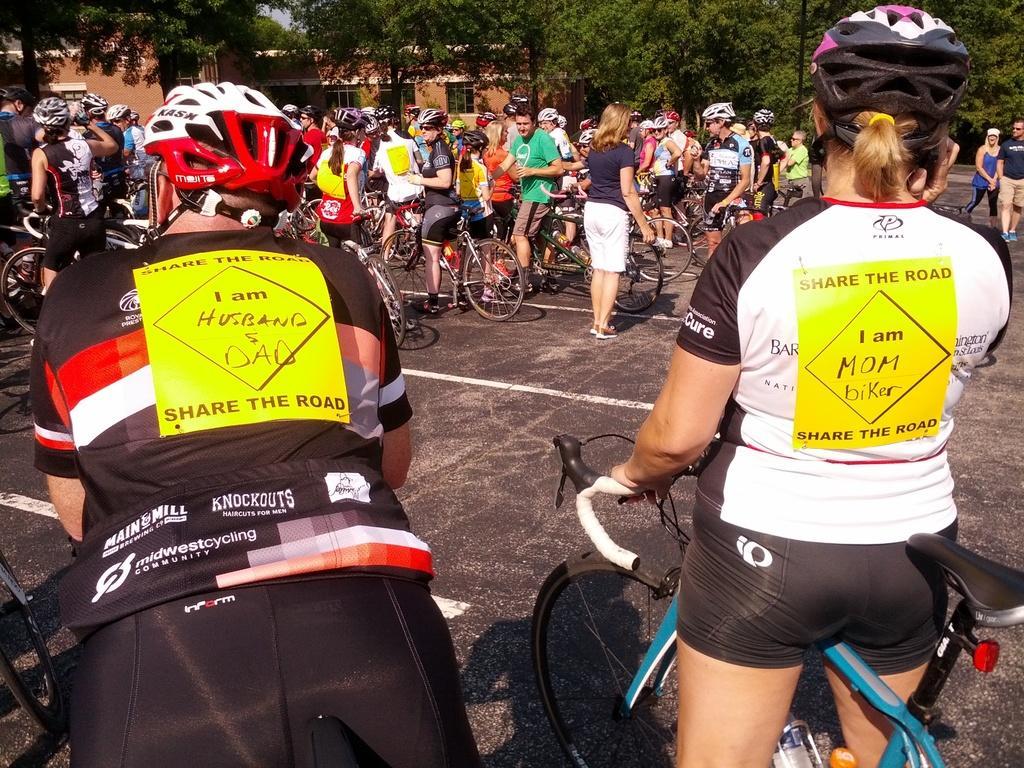In one or two sentences, can you explain what this image depicts? As we can see in the image there are bicycles, group of people here and there, houses and trees. 